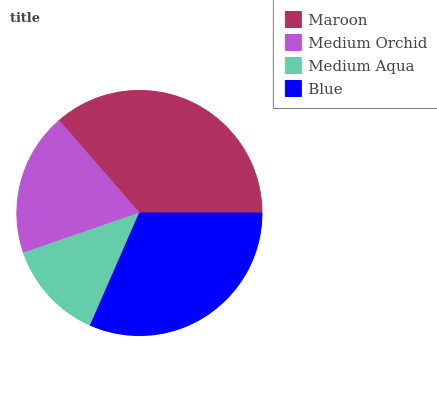Is Medium Aqua the minimum?
Answer yes or no. Yes. Is Maroon the maximum?
Answer yes or no. Yes. Is Medium Orchid the minimum?
Answer yes or no. No. Is Medium Orchid the maximum?
Answer yes or no. No. Is Maroon greater than Medium Orchid?
Answer yes or no. Yes. Is Medium Orchid less than Maroon?
Answer yes or no. Yes. Is Medium Orchid greater than Maroon?
Answer yes or no. No. Is Maroon less than Medium Orchid?
Answer yes or no. No. Is Blue the high median?
Answer yes or no. Yes. Is Medium Orchid the low median?
Answer yes or no. Yes. Is Maroon the high median?
Answer yes or no. No. Is Maroon the low median?
Answer yes or no. No. 